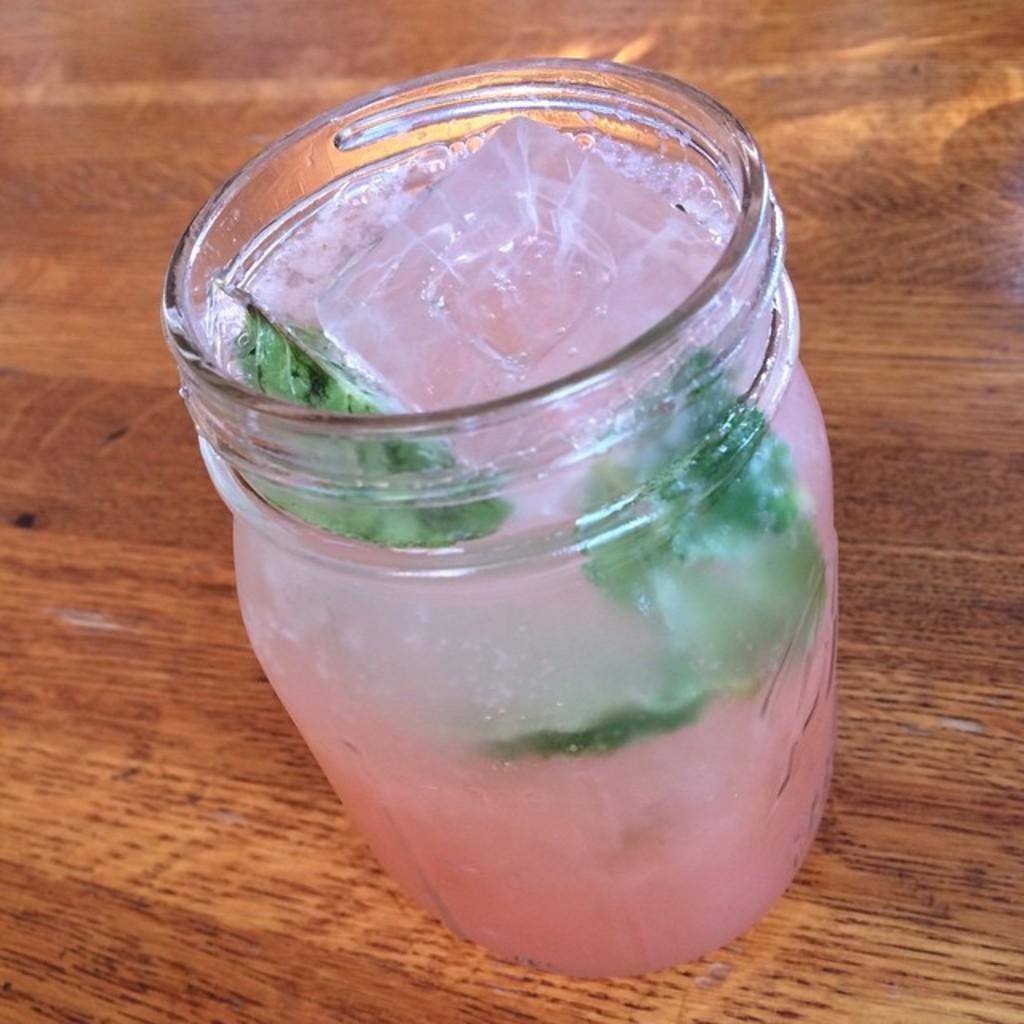Please provide a concise description of this image. In the middle of this image, there is a bottle having ice cube, leaves and pink color juice in it. This bottle is placed on a wooden table. And the background is brown in color. 